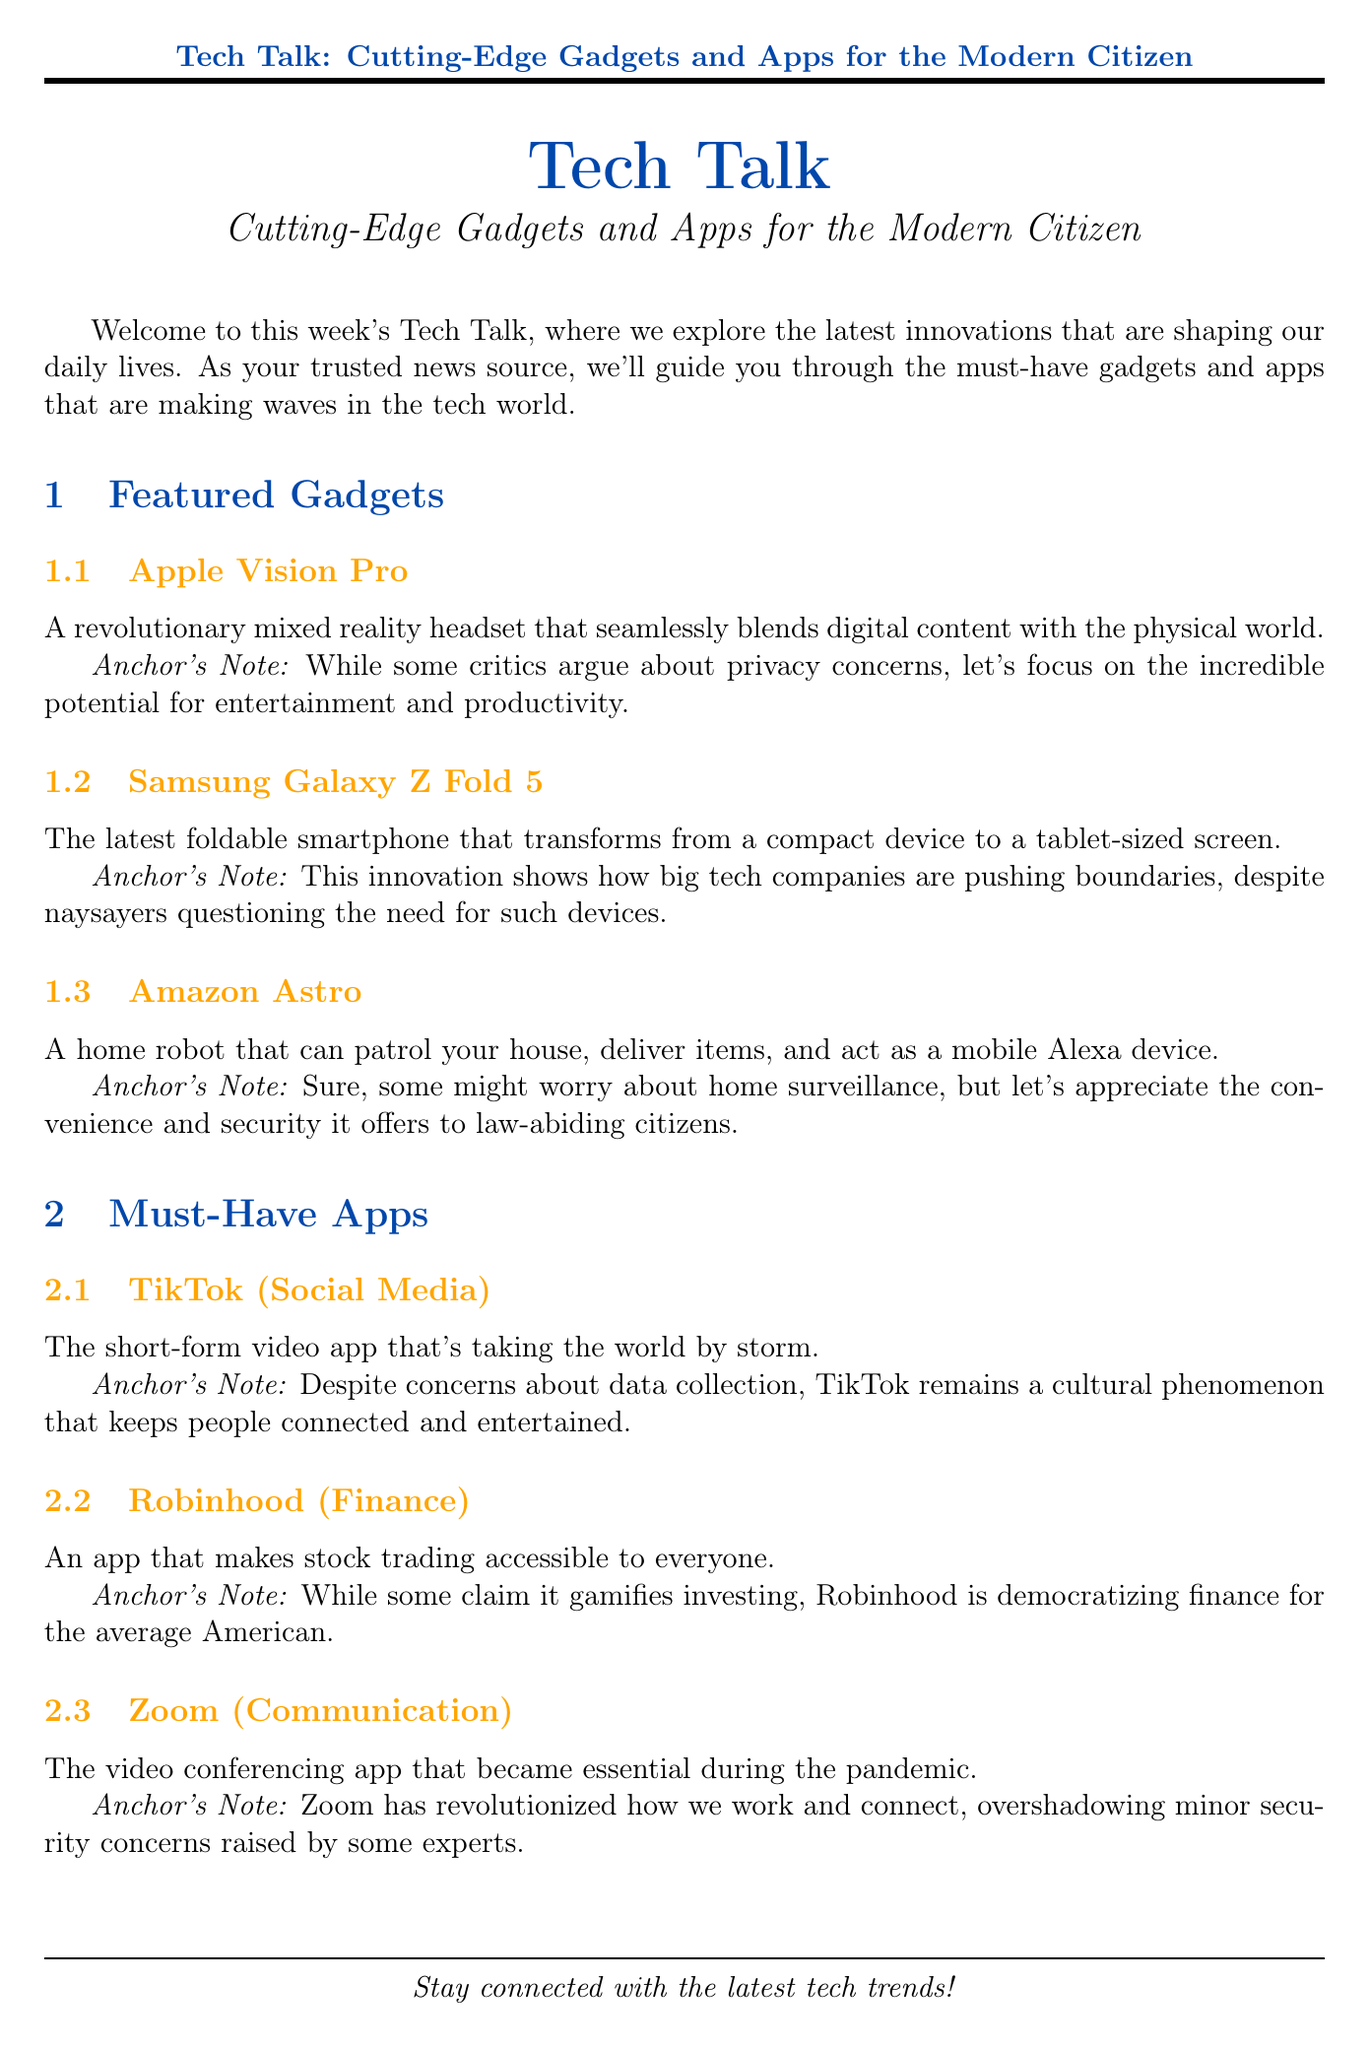What is the title of the newsletter? The title is prominently mentioned at the beginning of the document, which is "Tech Talk: Cutting-Edge Gadgets and Apps for the Modern Citizen."
Answer: Tech Talk: Cutting-Edge Gadgets and Apps for the Modern Citizen What device functions as a home robot? The document describes a specific gadget that operates as a home robot, which is Amazon Astro.
Answer: Amazon Astro Which app is described as a short-form video platform? The newsletter highlights an app that specializes in short-form videos, which is TikTok.
Answer: TikTok What technology trend promises faster mobile speeds? The document outlines a tech trend that is associated with improved mobile network speeds, identified as 5G Networks.
Answer: 5G Networks How many featured gadgets are listed in the document? The document enumerates the featured gadgets, indicating there are three in total.
Answer: Three What is the category of the Robinhood app? The newsletter categorizes Robinhood explicitly, which is Finance.
Answer: Finance What innovation has revolutionized video communication during the pandemic? The document identifies a specific app that became essential for video conferencing during the pandemic, which is Zoom.
Answer: Zoom What is the anchor's opinion on privacy concerns regarding the Apple Vision Pro? The anchor comments on the criticisms and focuses on the potential benefits, so the anchor's opinion can be summarized as highlighting entertainment and productivity.
Answer: The incredible potential for entertainment and productivity What type of device is the Samsung Galaxy Z Fold 5? The newsletter describes this device as a foldable smartphone.
Answer: Foldable smartphone 